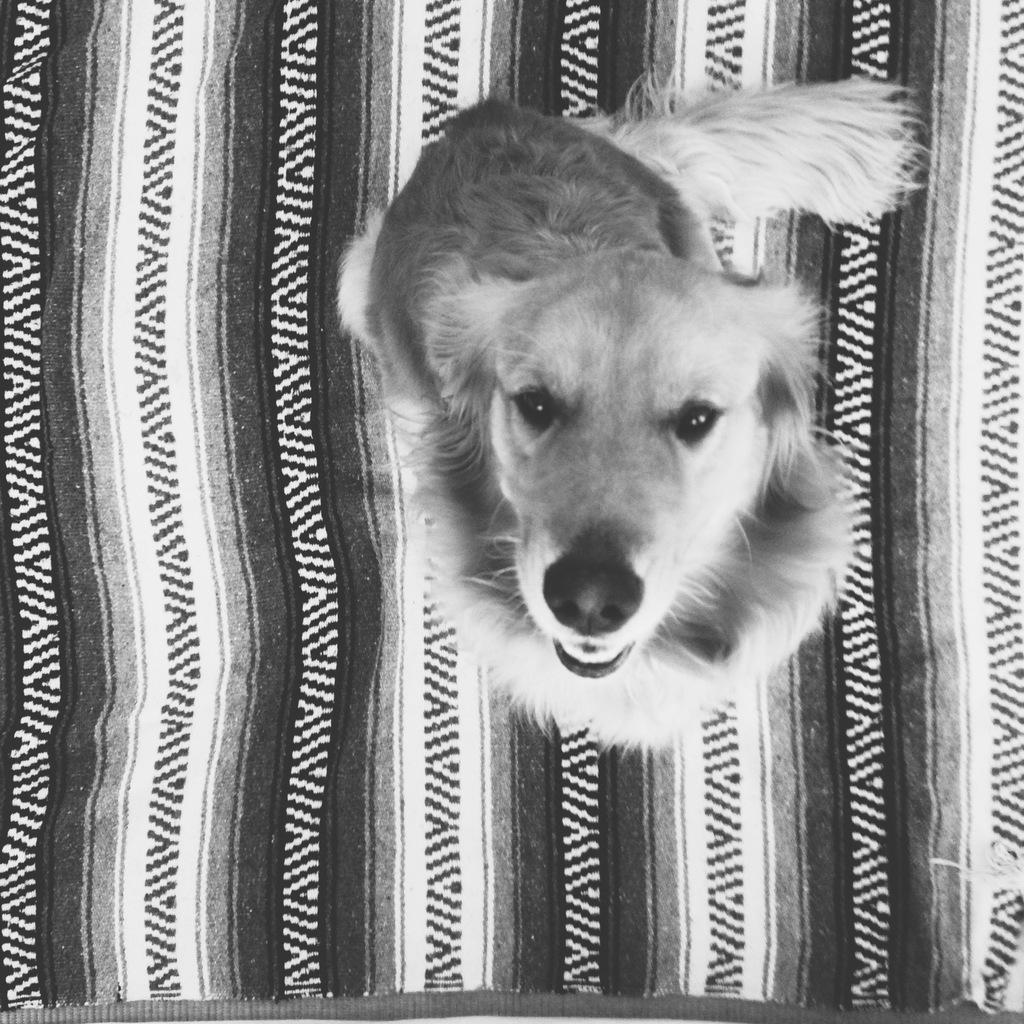What type of animal is in the image? There is a dog in the image. What is the dog positioned on in the image? The dog is on a cloth. Where is the squirrel located in the image? There is no squirrel present in the image. What type of plant is growing on the cloth in the image? There is no plant, such as clover, present in the image. 